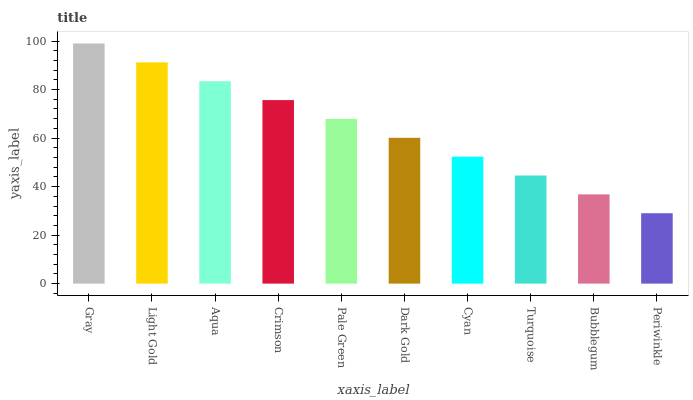Is Light Gold the minimum?
Answer yes or no. No. Is Light Gold the maximum?
Answer yes or no. No. Is Gray greater than Light Gold?
Answer yes or no. Yes. Is Light Gold less than Gray?
Answer yes or no. Yes. Is Light Gold greater than Gray?
Answer yes or no. No. Is Gray less than Light Gold?
Answer yes or no. No. Is Pale Green the high median?
Answer yes or no. Yes. Is Dark Gold the low median?
Answer yes or no. Yes. Is Periwinkle the high median?
Answer yes or no. No. Is Aqua the low median?
Answer yes or no. No. 